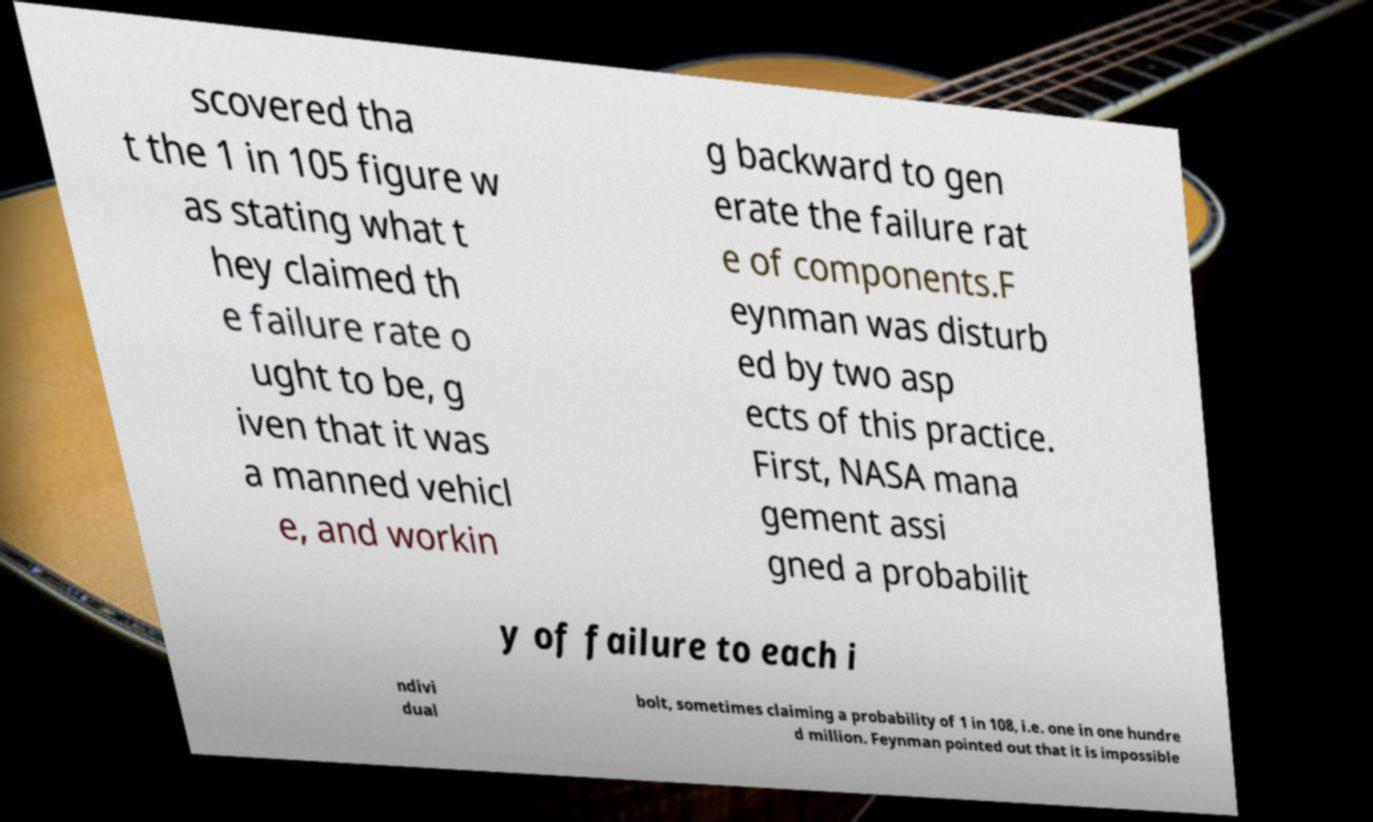Can you accurately transcribe the text from the provided image for me? scovered tha t the 1 in 105 figure w as stating what t hey claimed th e failure rate o ught to be, g iven that it was a manned vehicl e, and workin g backward to gen erate the failure rat e of components.F eynman was disturb ed by two asp ects of this practice. First, NASA mana gement assi gned a probabilit y of failure to each i ndivi dual bolt, sometimes claiming a probability of 1 in 108, i.e. one in one hundre d million. Feynman pointed out that it is impossible 